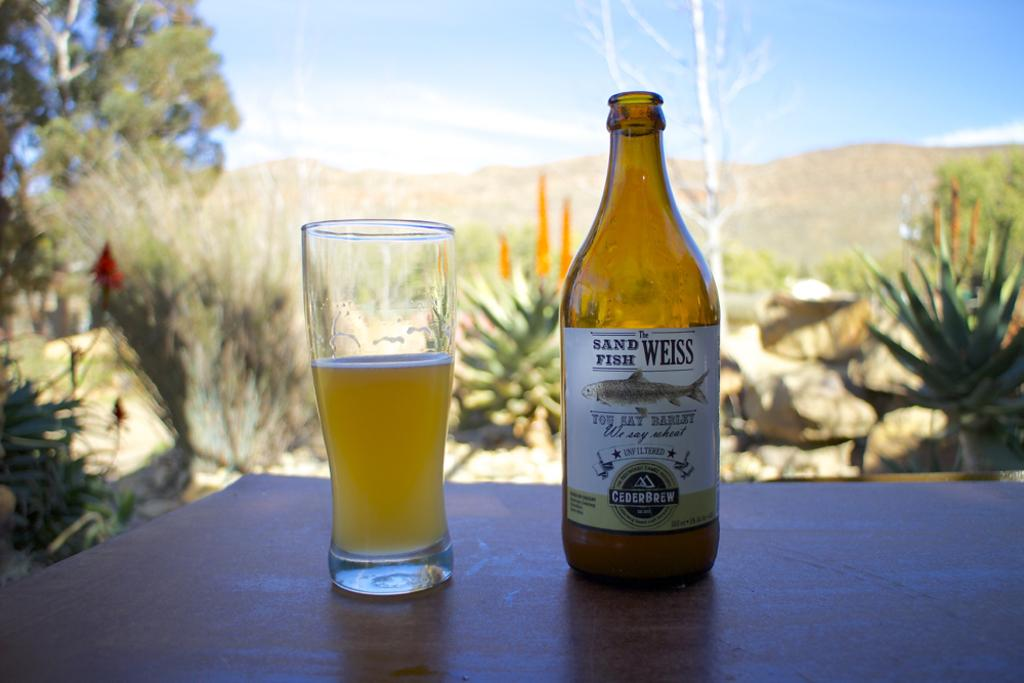<image>
Write a terse but informative summary of the picture. a bottle of cederbrew sits beside a glass with liquid in it 